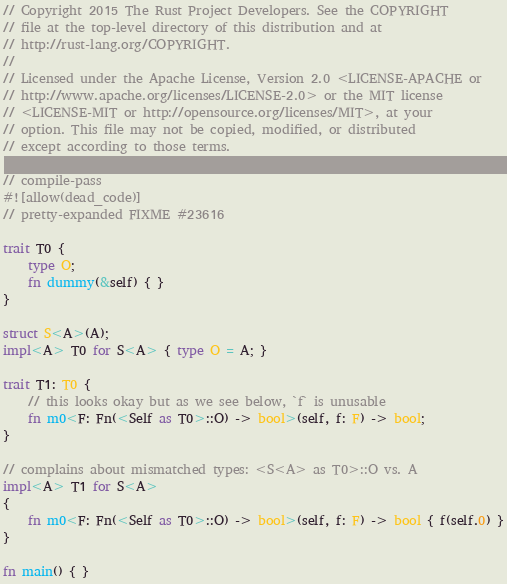<code> <loc_0><loc_0><loc_500><loc_500><_Rust_>// Copyright 2015 The Rust Project Developers. See the COPYRIGHT
// file at the top-level directory of this distribution and at
// http://rust-lang.org/COPYRIGHT.
//
// Licensed under the Apache License, Version 2.0 <LICENSE-APACHE or
// http://www.apache.org/licenses/LICENSE-2.0> or the MIT license
// <LICENSE-MIT or http://opensource.org/licenses/MIT>, at your
// option. This file may not be copied, modified, or distributed
// except according to those terms.

// compile-pass
#![allow(dead_code)]
// pretty-expanded FIXME #23616

trait T0 {
    type O;
    fn dummy(&self) { }
}

struct S<A>(A);
impl<A> T0 for S<A> { type O = A; }

trait T1: T0 {
    // this looks okay but as we see below, `f` is unusable
    fn m0<F: Fn(<Self as T0>::O) -> bool>(self, f: F) -> bool;
}

// complains about mismatched types: <S<A> as T0>::O vs. A
impl<A> T1 for S<A>
{
    fn m0<F: Fn(<Self as T0>::O) -> bool>(self, f: F) -> bool { f(self.0) }
}

fn main() { }
</code> 